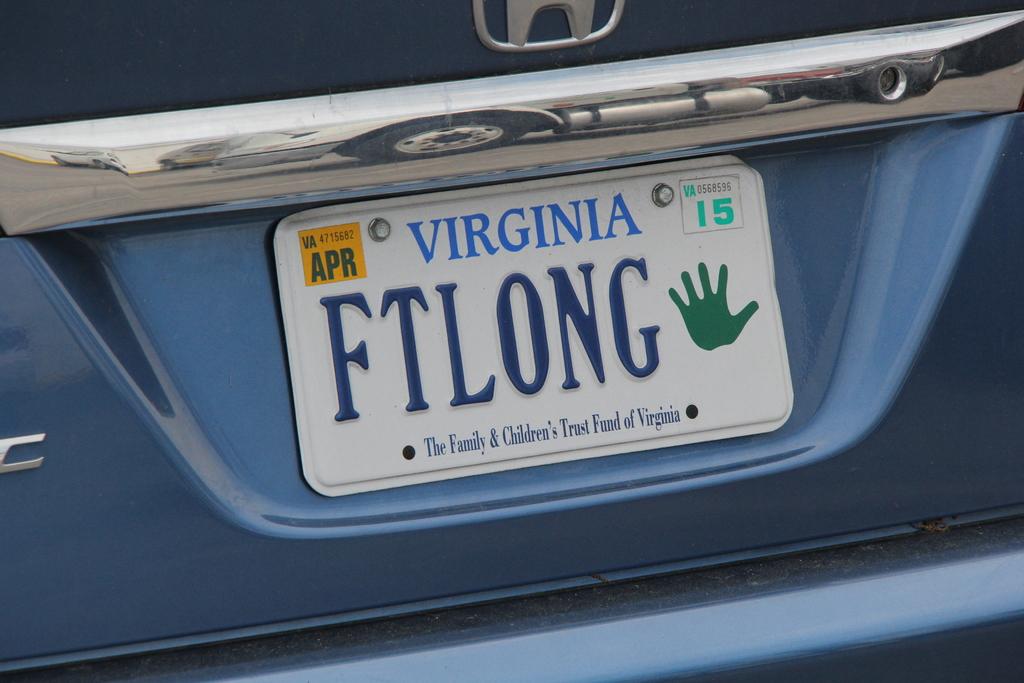What state is the license plate from?
Your answer should be compact. Virginia. 